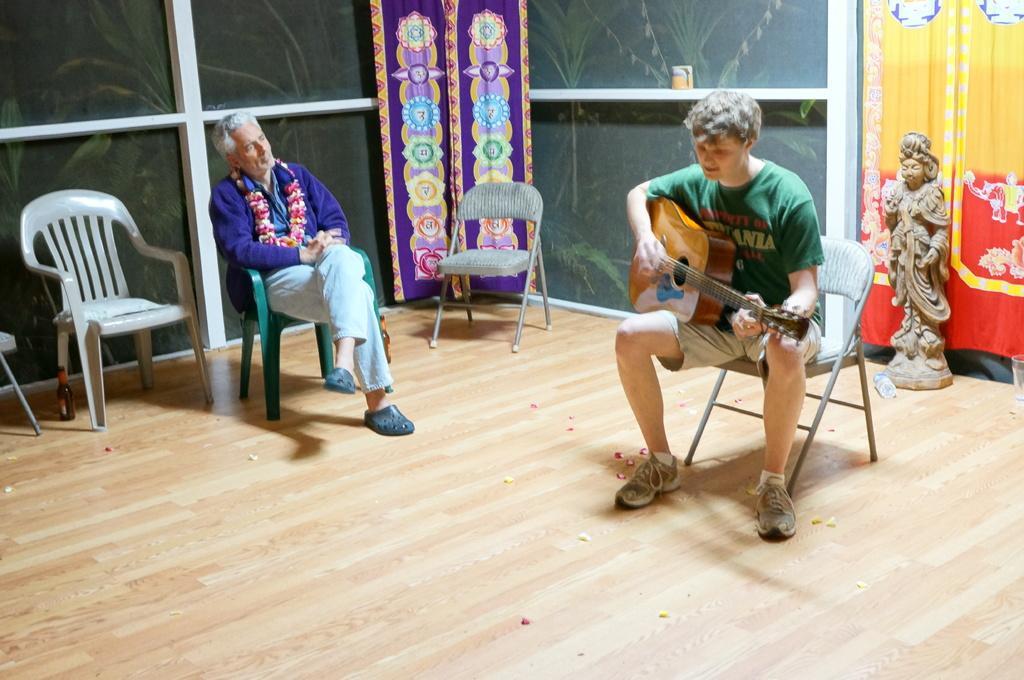Please provide a concise description of this image. In this picture there is a man sitting on a chair and another person is playing the guitar 